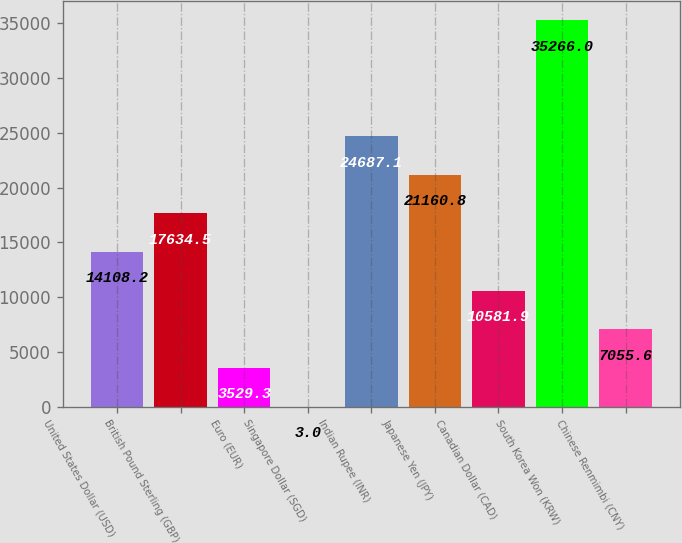Convert chart to OTSL. <chart><loc_0><loc_0><loc_500><loc_500><bar_chart><fcel>United States Dollar (USD)<fcel>British Pound Sterling (GBP)<fcel>Euro (EUR)<fcel>Singapore Dollar (SGD)<fcel>Indian Rupee (INR)<fcel>Japanese Yen (JPY)<fcel>Canadian Dollar (CAD)<fcel>South Korea Won (KRW)<fcel>Chinese Renmimbi (CNY)<nl><fcel>14108.2<fcel>17634.5<fcel>3529.3<fcel>3<fcel>24687.1<fcel>21160.8<fcel>10581.9<fcel>35266<fcel>7055.6<nl></chart> 